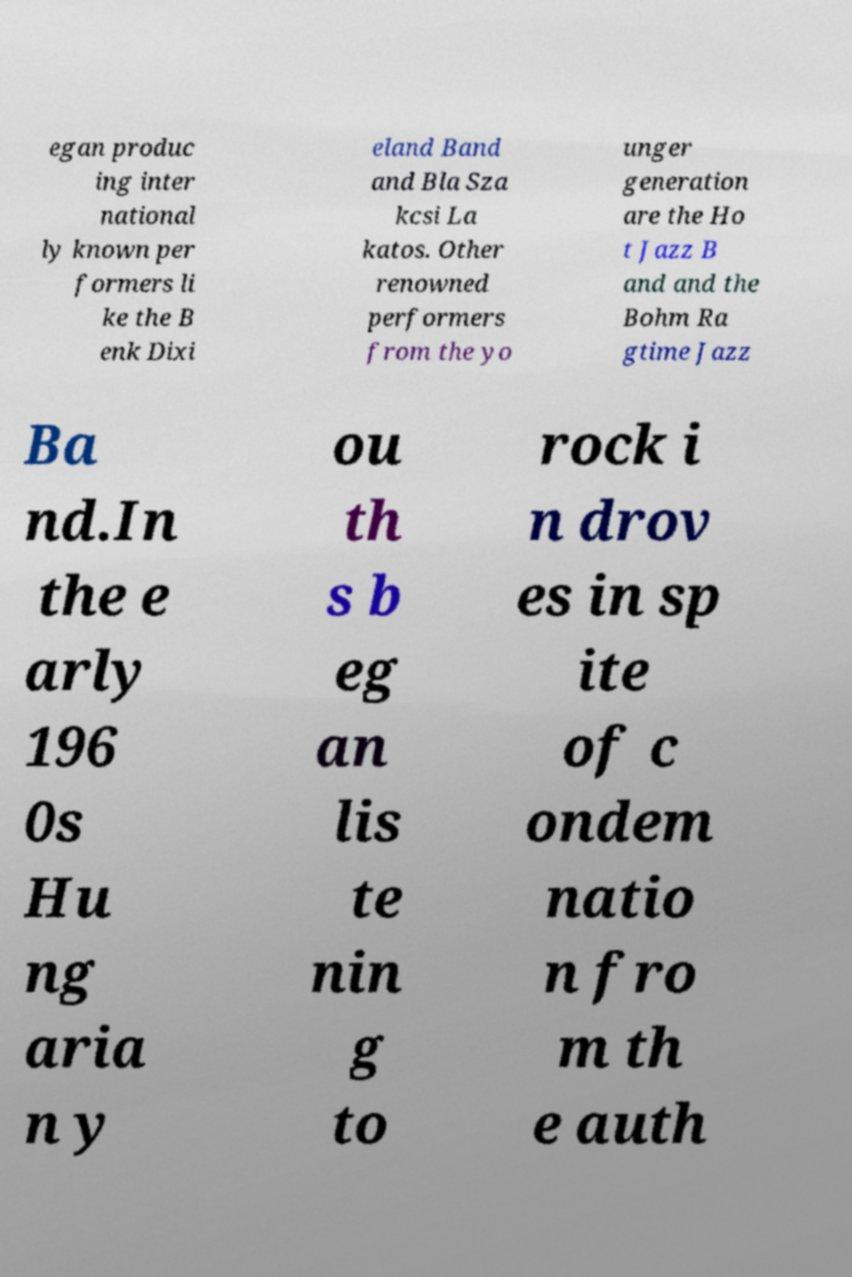What messages or text are displayed in this image? I need them in a readable, typed format. egan produc ing inter national ly known per formers li ke the B enk Dixi eland Band and Bla Sza kcsi La katos. Other renowned performers from the yo unger generation are the Ho t Jazz B and and the Bohm Ra gtime Jazz Ba nd.In the e arly 196 0s Hu ng aria n y ou th s b eg an lis te nin g to rock i n drov es in sp ite of c ondem natio n fro m th e auth 